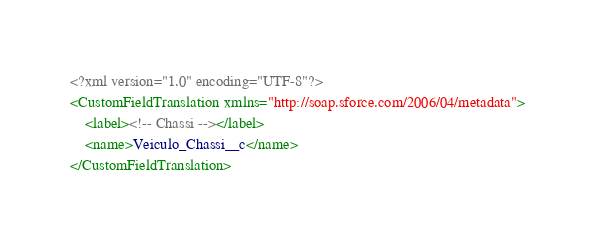<code> <loc_0><loc_0><loc_500><loc_500><_XML_><?xml version="1.0" encoding="UTF-8"?>
<CustomFieldTranslation xmlns="http://soap.sforce.com/2006/04/metadata">
    <label><!-- Chassi --></label>
    <name>Veiculo_Chassi__c</name>
</CustomFieldTranslation>
</code> 